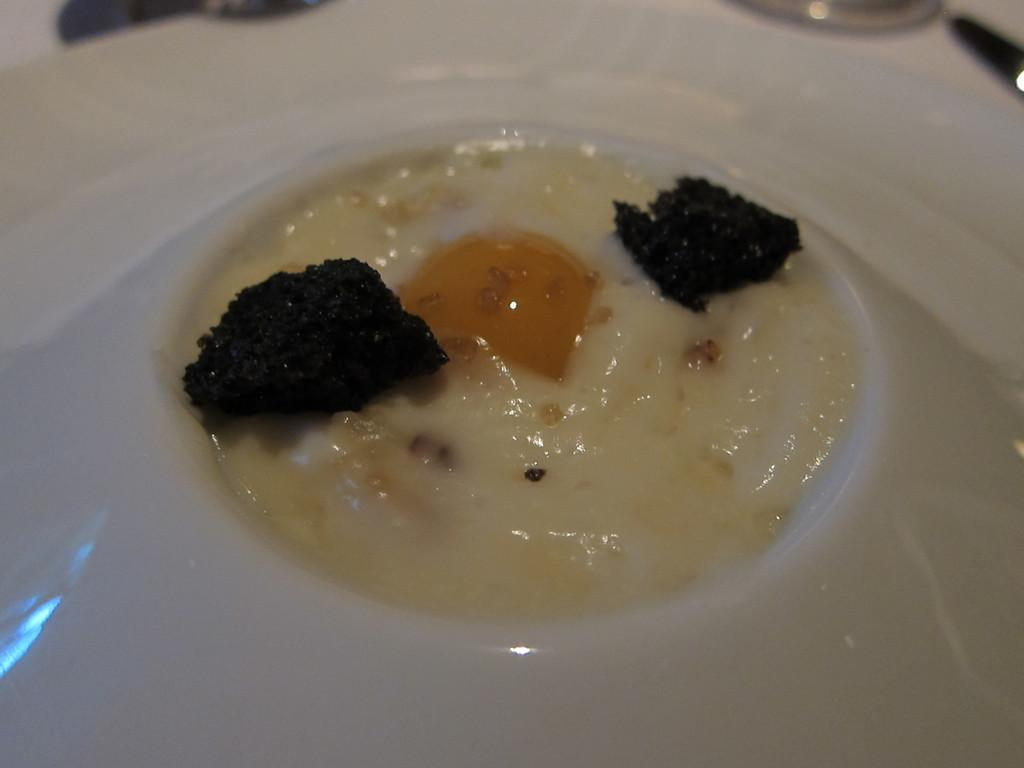What is in the bowl that is visible in the image? The bowl contains food. What is located at the bottom of the image? There is a plate at the bottom of the image. Where is the plate situated? The plate is on a table. What type of boat can be seen in the aftermath of the image? There is no boat present in the image, nor is there any mention of an aftermath. 